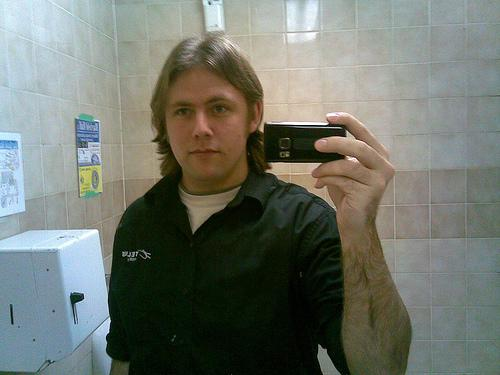Question: how many people are there?
Choices:
A. One.
B. Two.
C. Three.
D. Four.
Answer with the letter. Answer: A Question: where was the photo taken?
Choices:
A. Kitchen.
B. Bathroom.
C. Livingroom.
D. Diningroom.
Answer with the letter. Answer: B Question: what type of scene is this?
Choices:
A. Outdoor.
B. Mountain.
C. Indoor.
D. Ocean.
Answer with the letter. Answer: C Question: what gender is the person?
Choices:
A. Female.
B. Male.
C. Androgynous.
D. Male with feminine characteristics.
Answer with the letter. Answer: B Question: who is in the photo?
Choices:
A. A man.
B. A woman.
C. A boy.
D. The girl.
Answer with the letter. Answer: A 